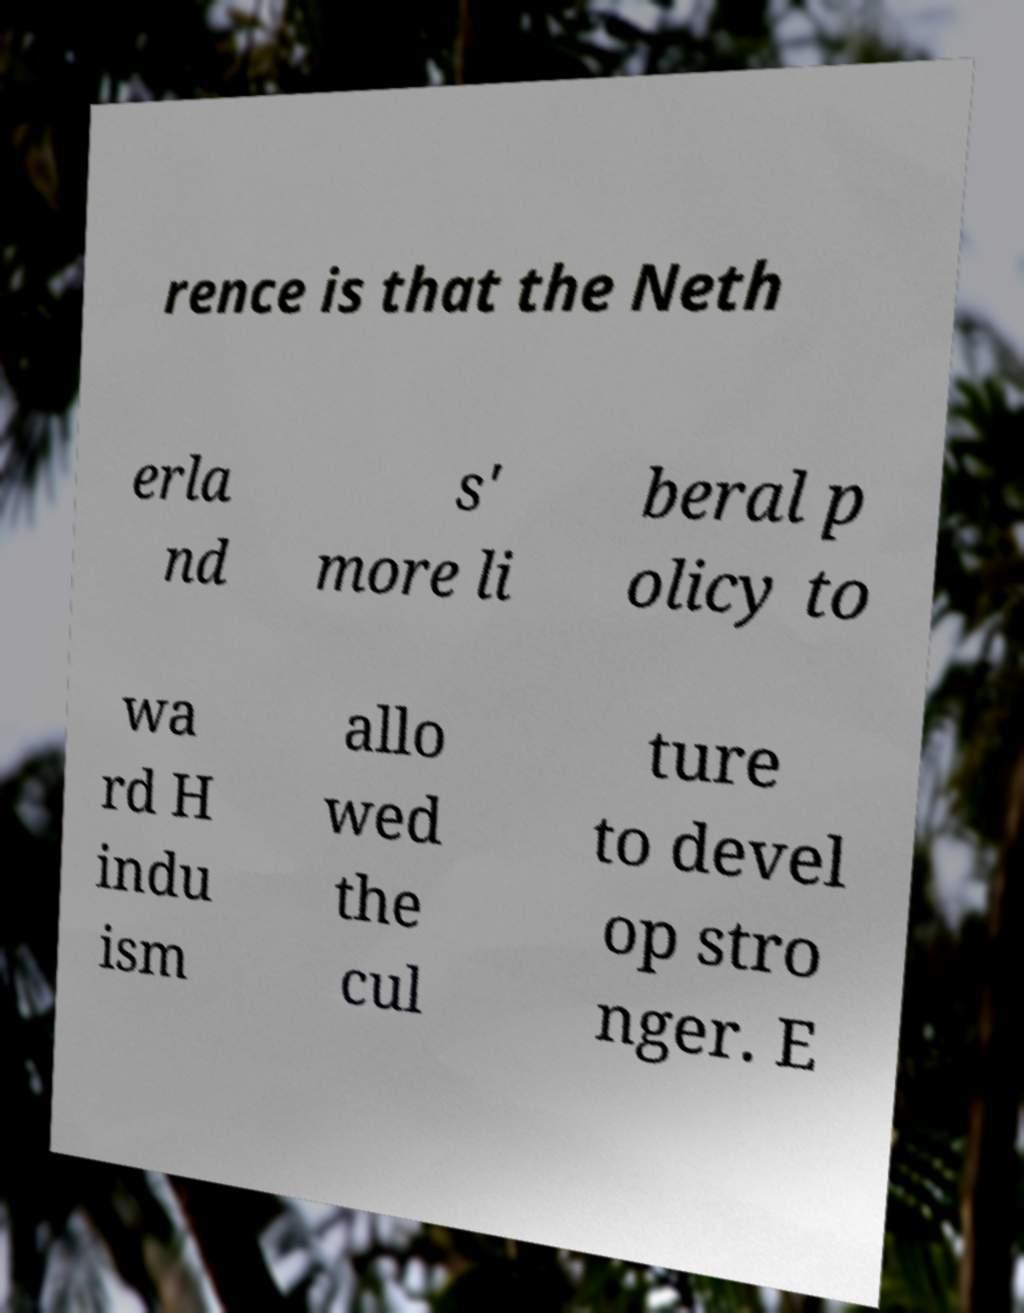Could you extract and type out the text from this image? rence is that the Neth erla nd s' more li beral p olicy to wa rd H indu ism allo wed the cul ture to devel op stro nger. E 